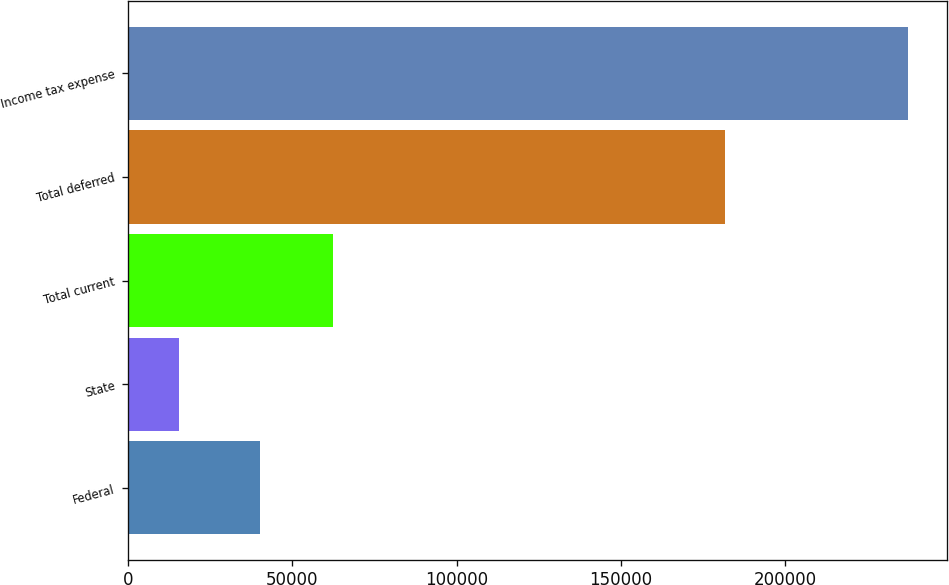Convert chart to OTSL. <chart><loc_0><loc_0><loc_500><loc_500><bar_chart><fcel>Federal<fcel>State<fcel>Total current<fcel>Total deferred<fcel>Income tax expense<nl><fcel>40115<fcel>15598<fcel>62291.2<fcel>181647<fcel>237360<nl></chart> 